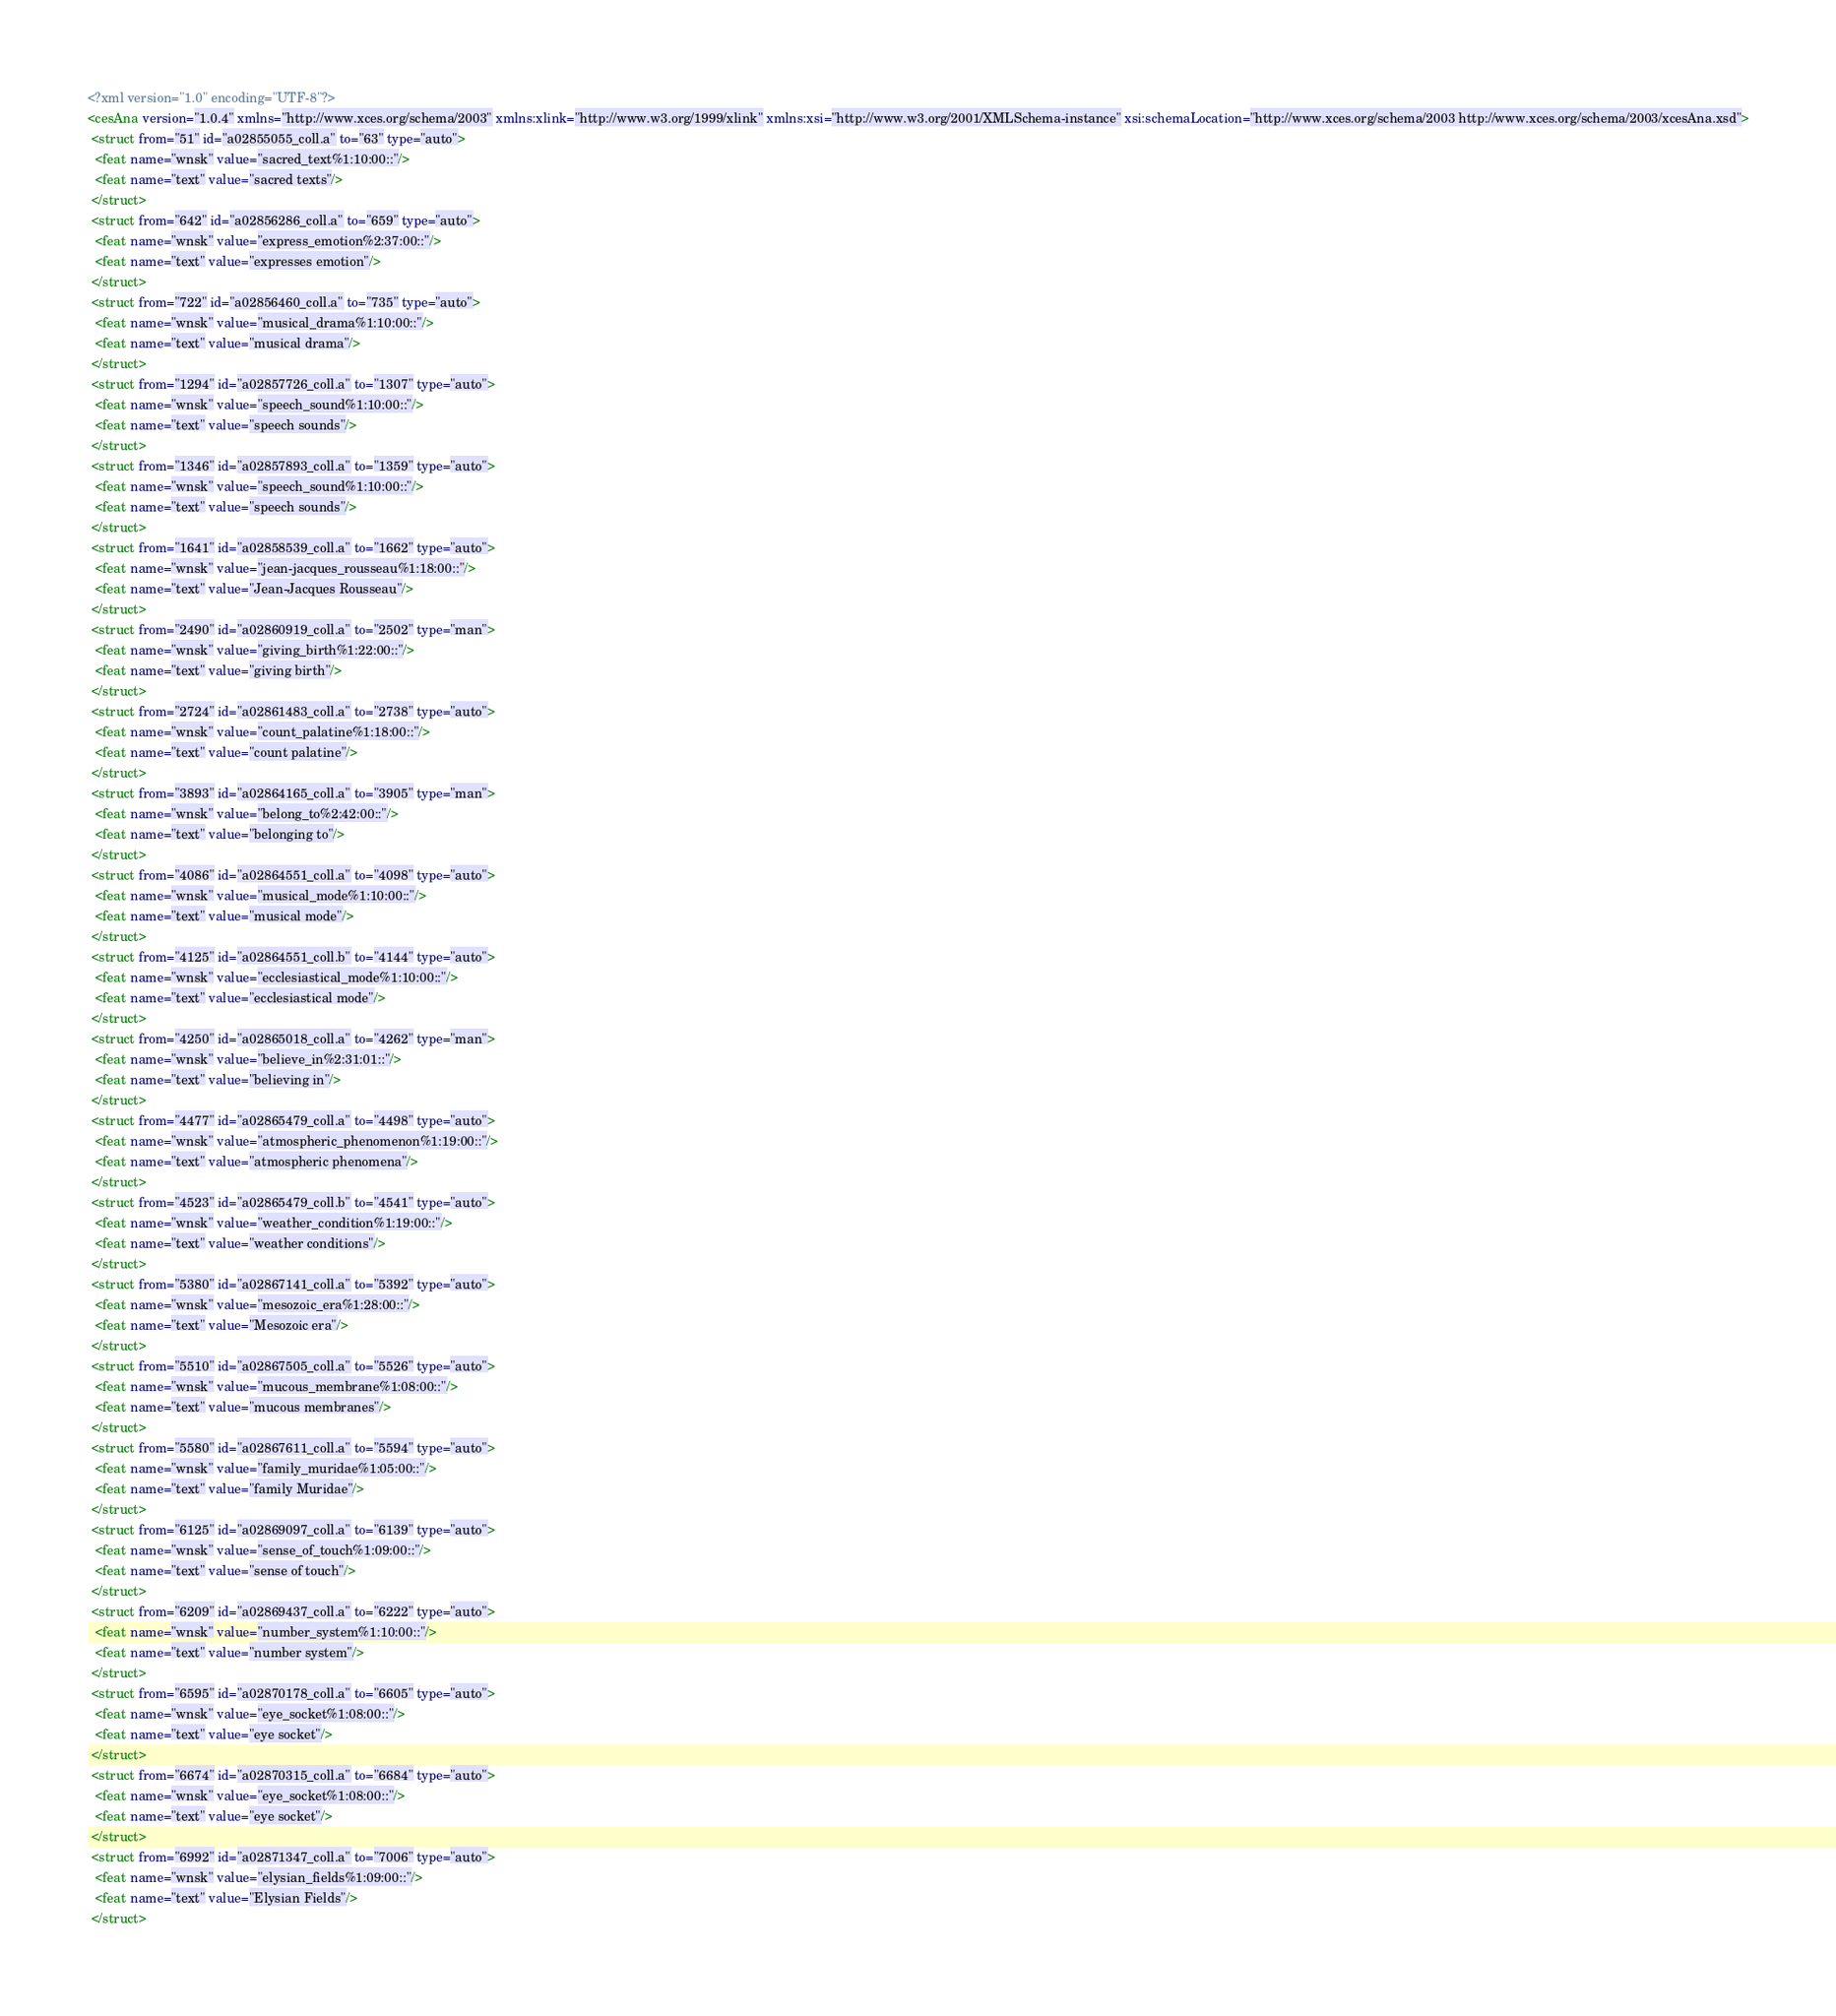Convert code to text. <code><loc_0><loc_0><loc_500><loc_500><_XML_><?xml version="1.0" encoding="UTF-8"?>
<cesAna version="1.0.4" xmlns="http://www.xces.org/schema/2003" xmlns:xlink="http://www.w3.org/1999/xlink" xmlns:xsi="http://www.w3.org/2001/XMLSchema-instance" xsi:schemaLocation="http://www.xces.org/schema/2003 http://www.xces.org/schema/2003/xcesAna.xsd">
 <struct from="51" id="a02855055_coll.a" to="63" type="auto">
  <feat name="wnsk" value="sacred_text%1:10:00::"/>
  <feat name="text" value="sacred texts"/>
 </struct>
 <struct from="642" id="a02856286_coll.a" to="659" type="auto">
  <feat name="wnsk" value="express_emotion%2:37:00::"/>
  <feat name="text" value="expresses emotion"/>
 </struct>
 <struct from="722" id="a02856460_coll.a" to="735" type="auto">
  <feat name="wnsk" value="musical_drama%1:10:00::"/>
  <feat name="text" value="musical drama"/>
 </struct>
 <struct from="1294" id="a02857726_coll.a" to="1307" type="auto">
  <feat name="wnsk" value="speech_sound%1:10:00::"/>
  <feat name="text" value="speech sounds"/>
 </struct>
 <struct from="1346" id="a02857893_coll.a" to="1359" type="auto">
  <feat name="wnsk" value="speech_sound%1:10:00::"/>
  <feat name="text" value="speech sounds"/>
 </struct>
 <struct from="1641" id="a02858539_coll.a" to="1662" type="auto">
  <feat name="wnsk" value="jean-jacques_rousseau%1:18:00::"/>
  <feat name="text" value="Jean-Jacques Rousseau"/>
 </struct>
 <struct from="2490" id="a02860919_coll.a" to="2502" type="man">
  <feat name="wnsk" value="giving_birth%1:22:00::"/>
  <feat name="text" value="giving birth"/>
 </struct>
 <struct from="2724" id="a02861483_coll.a" to="2738" type="auto">
  <feat name="wnsk" value="count_palatine%1:18:00::"/>
  <feat name="text" value="count palatine"/>
 </struct>
 <struct from="3893" id="a02864165_coll.a" to="3905" type="man">
  <feat name="wnsk" value="belong_to%2:42:00::"/>
  <feat name="text" value="belonging to"/>
 </struct>
 <struct from="4086" id="a02864551_coll.a" to="4098" type="auto">
  <feat name="wnsk" value="musical_mode%1:10:00::"/>
  <feat name="text" value="musical mode"/>
 </struct>
 <struct from="4125" id="a02864551_coll.b" to="4144" type="auto">
  <feat name="wnsk" value="ecclesiastical_mode%1:10:00::"/>
  <feat name="text" value="ecclesiastical mode"/>
 </struct>
 <struct from="4250" id="a02865018_coll.a" to="4262" type="man">
  <feat name="wnsk" value="believe_in%2:31:01::"/>
  <feat name="text" value="believing in"/>
 </struct>
 <struct from="4477" id="a02865479_coll.a" to="4498" type="auto">
  <feat name="wnsk" value="atmospheric_phenomenon%1:19:00::"/>
  <feat name="text" value="atmospheric phenomena"/>
 </struct>
 <struct from="4523" id="a02865479_coll.b" to="4541" type="auto">
  <feat name="wnsk" value="weather_condition%1:19:00::"/>
  <feat name="text" value="weather conditions"/>
 </struct>
 <struct from="5380" id="a02867141_coll.a" to="5392" type="auto">
  <feat name="wnsk" value="mesozoic_era%1:28:00::"/>
  <feat name="text" value="Mesozoic era"/>
 </struct>
 <struct from="5510" id="a02867505_coll.a" to="5526" type="auto">
  <feat name="wnsk" value="mucous_membrane%1:08:00::"/>
  <feat name="text" value="mucous membranes"/>
 </struct>
 <struct from="5580" id="a02867611_coll.a" to="5594" type="auto">
  <feat name="wnsk" value="family_muridae%1:05:00::"/>
  <feat name="text" value="family Muridae"/>
 </struct>
 <struct from="6125" id="a02869097_coll.a" to="6139" type="auto">
  <feat name="wnsk" value="sense_of_touch%1:09:00::"/>
  <feat name="text" value="sense of touch"/>
 </struct>
 <struct from="6209" id="a02869437_coll.a" to="6222" type="auto">
  <feat name="wnsk" value="number_system%1:10:00::"/>
  <feat name="text" value="number system"/>
 </struct>
 <struct from="6595" id="a02870178_coll.a" to="6605" type="auto">
  <feat name="wnsk" value="eye_socket%1:08:00::"/>
  <feat name="text" value="eye socket"/>
 </struct>
 <struct from="6674" id="a02870315_coll.a" to="6684" type="auto">
  <feat name="wnsk" value="eye_socket%1:08:00::"/>
  <feat name="text" value="eye socket"/>
 </struct>
 <struct from="6992" id="a02871347_coll.a" to="7006" type="auto">
  <feat name="wnsk" value="elysian_fields%1:09:00::"/>
  <feat name="text" value="Elysian Fields"/>
 </struct></code> 